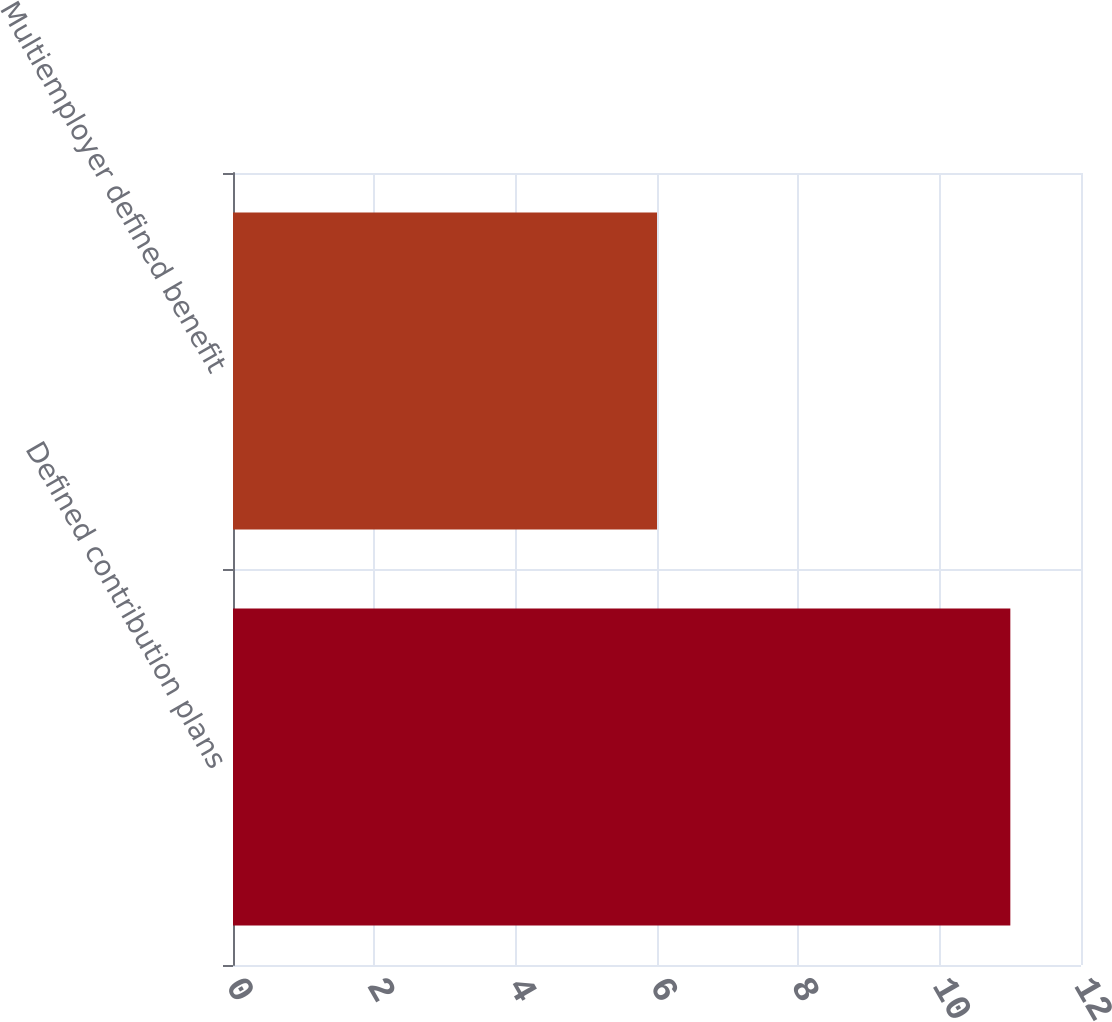Convert chart to OTSL. <chart><loc_0><loc_0><loc_500><loc_500><bar_chart><fcel>Defined contribution plans<fcel>Multiemployer defined benefit<nl><fcel>11<fcel>6<nl></chart> 